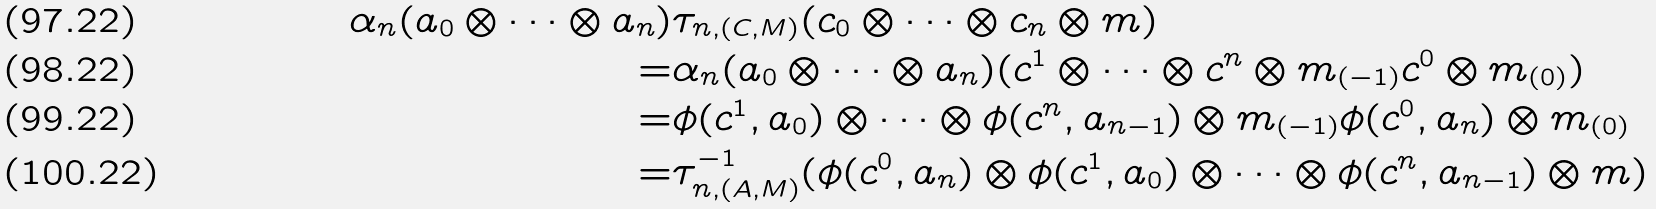Convert formula to latex. <formula><loc_0><loc_0><loc_500><loc_500>\alpha _ { n } ( a _ { 0 } \otimes \cdots \otimes a _ { n } ) & \tau _ { n , ( C , M ) } ( c _ { 0 } \otimes \cdots \otimes c _ { n } \otimes m ) \\ = & \alpha _ { n } ( a _ { 0 } \otimes \cdots \otimes a _ { n } ) ( c ^ { 1 } \otimes \cdots \otimes c ^ { n } \otimes m _ { ( - 1 ) } c ^ { 0 } \otimes m _ { ( 0 ) } ) \\ = & \phi ( c ^ { 1 } , a _ { 0 } ) \otimes \cdots \otimes \phi ( c ^ { n } , a _ { n - 1 } ) \otimes m _ { ( - 1 ) } \phi ( c ^ { 0 } , a _ { n } ) \otimes m _ { ( 0 ) } \\ = & \tau _ { n , ( A , M ) } ^ { - 1 } ( \phi ( c ^ { 0 } , a _ { n } ) \otimes \phi ( c ^ { 1 } , a _ { 0 } ) \otimes \cdots \otimes \phi ( c ^ { n } , a _ { n - 1 } ) \otimes m )</formula> 